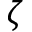<formula> <loc_0><loc_0><loc_500><loc_500>\zeta</formula> 